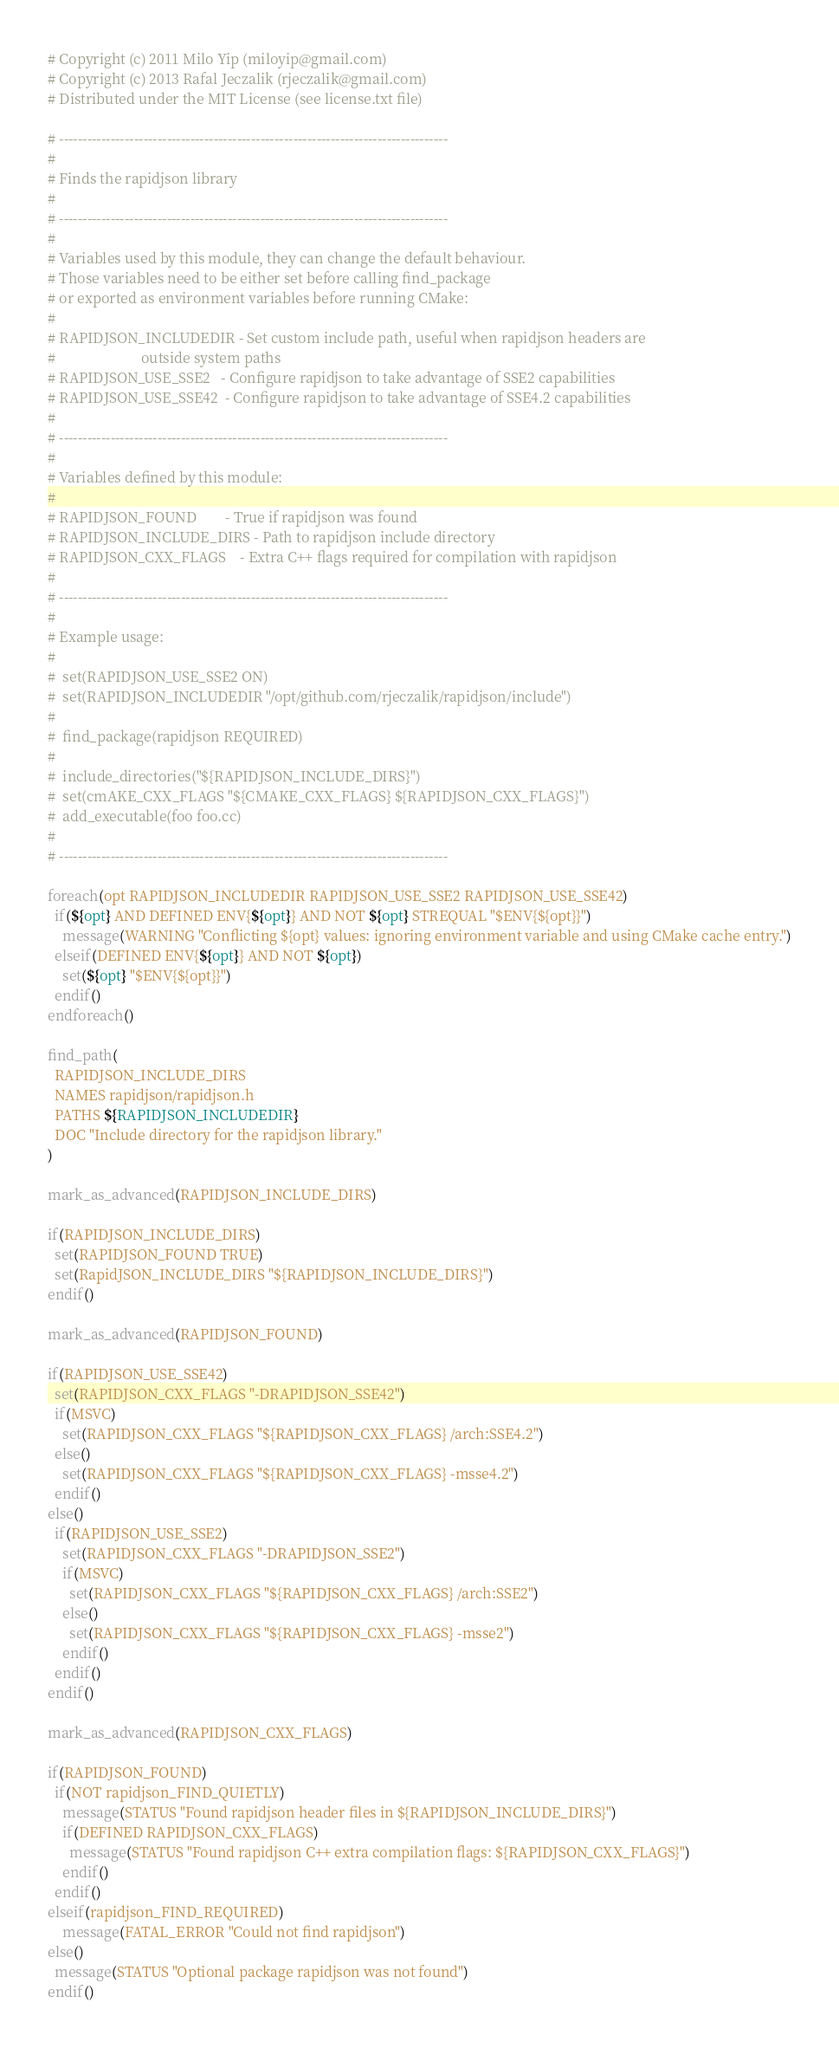Convert code to text. <code><loc_0><loc_0><loc_500><loc_500><_CMake_># Copyright (c) 2011 Milo Yip (miloyip@gmail.com)
# Copyright (c) 2013 Rafal Jeczalik (rjeczalik@gmail.com)
# Distributed under the MIT License (see license.txt file)

# -----------------------------------------------------------------------------------
#
# Finds the rapidjson library
#
# -----------------------------------------------------------------------------------
#
# Variables used by this module, they can change the default behaviour.
# Those variables need to be either set before calling find_package
# or exported as environment variables before running CMake:
#
# RAPIDJSON_INCLUDEDIR - Set custom include path, useful when rapidjson headers are
#                        outside system paths
# RAPIDJSON_USE_SSE2   - Configure rapidjson to take advantage of SSE2 capabilities
# RAPIDJSON_USE_SSE42  - Configure rapidjson to take advantage of SSE4.2 capabilities
#
# -----------------------------------------------------------------------------------
#
# Variables defined by this module:
#
# RAPIDJSON_FOUND        - True if rapidjson was found
# RAPIDJSON_INCLUDE_DIRS - Path to rapidjson include directory
# RAPIDJSON_CXX_FLAGS    - Extra C++ flags required for compilation with rapidjson
#
# -----------------------------------------------------------------------------------
#
# Example usage:
#
#  set(RAPIDJSON_USE_SSE2 ON)
#  set(RAPIDJSON_INCLUDEDIR "/opt/github.com/rjeczalik/rapidjson/include")
#
#  find_package(rapidjson REQUIRED)
#
#  include_directories("${RAPIDJSON_INCLUDE_DIRS}")
#  set(cmAKE_CXX_FLAGS "${CMAKE_CXX_FLAGS} ${RAPIDJSON_CXX_FLAGS}")
#  add_executable(foo foo.cc)
#
# -----------------------------------------------------------------------------------

foreach(opt RAPIDJSON_INCLUDEDIR RAPIDJSON_USE_SSE2 RAPIDJSON_USE_SSE42)
  if(${opt} AND DEFINED ENV{${opt}} AND NOT ${opt} STREQUAL "$ENV{${opt}}")
    message(WARNING "Conflicting ${opt} values: ignoring environment variable and using CMake cache entry.")
  elseif(DEFINED ENV{${opt}} AND NOT ${opt})
    set(${opt} "$ENV{${opt}}")
  endif()
endforeach()

find_path(
  RAPIDJSON_INCLUDE_DIRS
  NAMES rapidjson/rapidjson.h
  PATHS ${RAPIDJSON_INCLUDEDIR}
  DOC "Include directory for the rapidjson library."
)

mark_as_advanced(RAPIDJSON_INCLUDE_DIRS)

if(RAPIDJSON_INCLUDE_DIRS)
  set(RAPIDJSON_FOUND TRUE)
  set(RapidJSON_INCLUDE_DIRS "${RAPIDJSON_INCLUDE_DIRS}")
endif()

mark_as_advanced(RAPIDJSON_FOUND)

if(RAPIDJSON_USE_SSE42)
  set(RAPIDJSON_CXX_FLAGS "-DRAPIDJSON_SSE42")
  if(MSVC)
    set(RAPIDJSON_CXX_FLAGS "${RAPIDJSON_CXX_FLAGS} /arch:SSE4.2")
  else()
    set(RAPIDJSON_CXX_FLAGS "${RAPIDJSON_CXX_FLAGS} -msse4.2")
  endif()
else()
  if(RAPIDJSON_USE_SSE2)
    set(RAPIDJSON_CXX_FLAGS "-DRAPIDJSON_SSE2")
    if(MSVC)
      set(RAPIDJSON_CXX_FLAGS "${RAPIDJSON_CXX_FLAGS} /arch:SSE2")
    else()
      set(RAPIDJSON_CXX_FLAGS "${RAPIDJSON_CXX_FLAGS} -msse2")
    endif()
  endif()
endif()

mark_as_advanced(RAPIDJSON_CXX_FLAGS)

if(RAPIDJSON_FOUND)
  if(NOT rapidjson_FIND_QUIETLY)
    message(STATUS "Found rapidjson header files in ${RAPIDJSON_INCLUDE_DIRS}")
    if(DEFINED RAPIDJSON_CXX_FLAGS)
      message(STATUS "Found rapidjson C++ extra compilation flags: ${RAPIDJSON_CXX_FLAGS}")
    endif()
  endif()
elseif(rapidjson_FIND_REQUIRED)
    message(FATAL_ERROR "Could not find rapidjson")
else()
  message(STATUS "Optional package rapidjson was not found")
endif()
</code> 